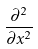<formula> <loc_0><loc_0><loc_500><loc_500>\frac { \partial ^ { 2 } } { \partial x ^ { 2 } }</formula> 